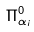Convert formula to latex. <formula><loc_0><loc_0><loc_500><loc_500>\Pi _ { \alpha _ { i } } ^ { 0 }</formula> 